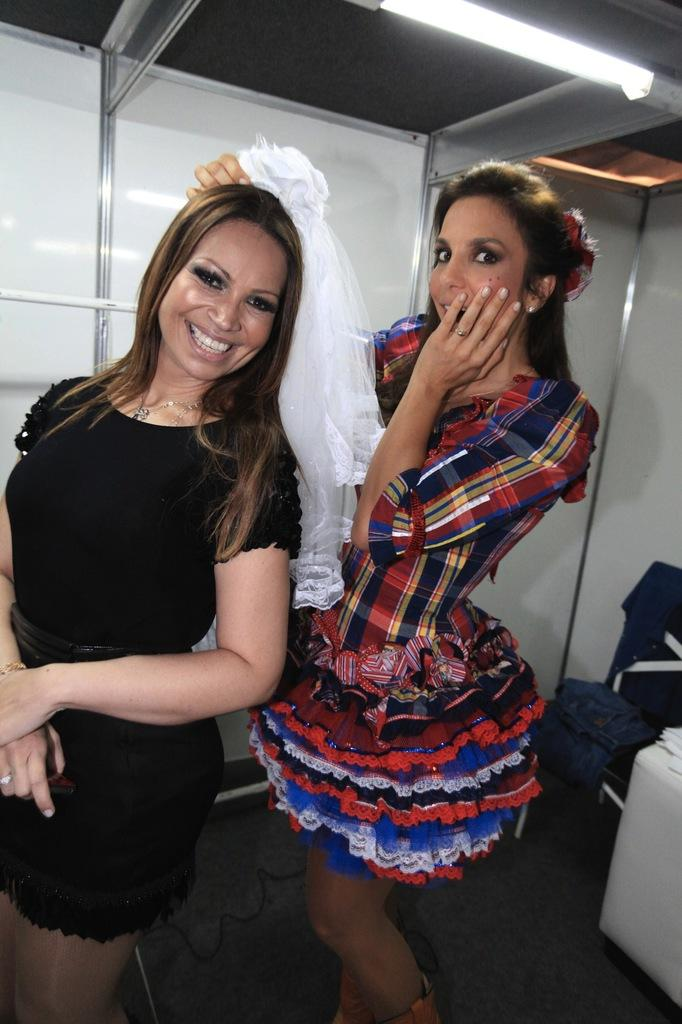How many people are in the image? There are two women in the image. What are the women doing in the image? The women are standing and smiling. What is on the chair in the image? There are clothes on the chair. What can be seen in the background of the image? There is a wall in the background of the image. What is providing illumination in the image? There is a light in the image. Can you tell me what type of pot is visible in the stream in the image? There is no pot or stream present in the image. 